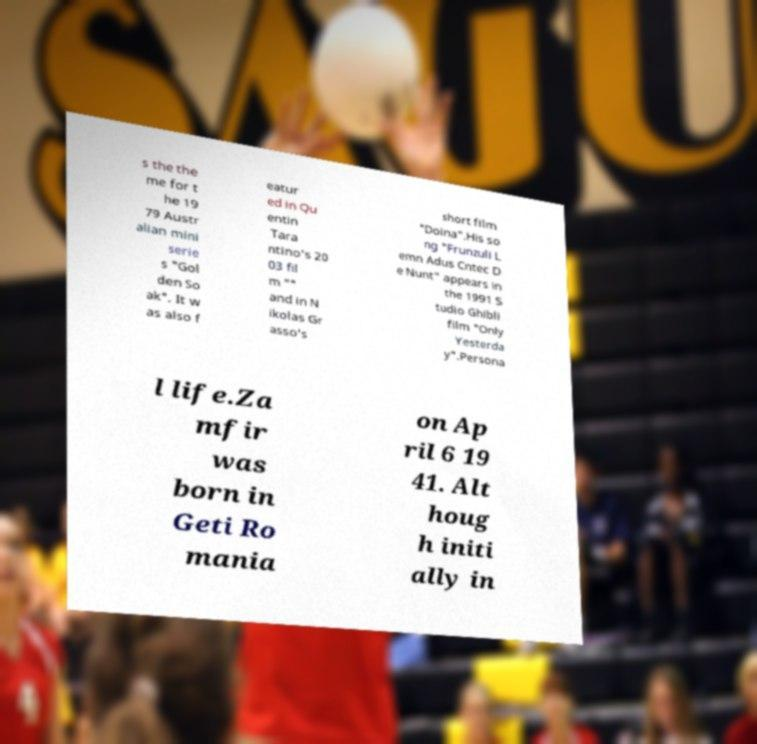Can you accurately transcribe the text from the provided image for me? s the the me for t he 19 79 Austr alian mini serie s "Gol den So ak". It w as also f eatur ed in Qu entin Tara ntino's 20 03 fil m "" and in N ikolas Gr asso's short film "Doina".His so ng "Frunzuli L emn Adus Cntec D e Nunt" appears in the 1991 S tudio Ghibli film "Only Yesterda y".Persona l life.Za mfir was born in Geti Ro mania on Ap ril 6 19 41. Alt houg h initi ally in 